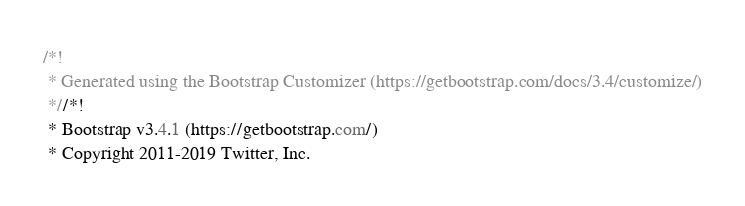Convert code to text. <code><loc_0><loc_0><loc_500><loc_500><_CSS_>/*!
 * Generated using the Bootstrap Customizer (https://getbootstrap.com/docs/3.4/customize/)
 *//*!
 * Bootstrap v3.4.1 (https://getbootstrap.com/)
 * Copyright 2011-2019 Twitter, Inc.</code> 